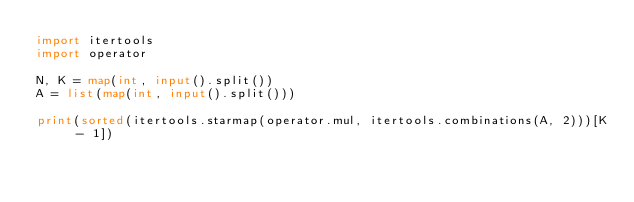<code> <loc_0><loc_0><loc_500><loc_500><_Python_>import itertools
import operator

N, K = map(int, input().split())
A = list(map(int, input().split()))

print(sorted(itertools.starmap(operator.mul, itertools.combinations(A, 2)))[K - 1])
</code> 